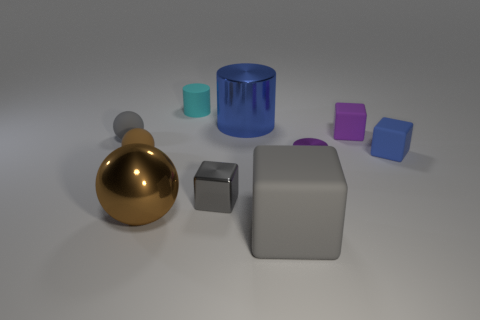Subtract all tiny purple blocks. How many blocks are left? 3 Subtract all gray cubes. How many cubes are left? 2 Subtract all blue balls. How many gray cubes are left? 2 Subtract 4 cubes. How many cubes are left? 0 Add 5 big rubber objects. How many big rubber objects are left? 6 Add 8 big gray cubes. How many big gray cubes exist? 9 Subtract 0 yellow blocks. How many objects are left? 10 Subtract all balls. How many objects are left? 7 Subtract all blue spheres. Subtract all gray cubes. How many spheres are left? 3 Subtract all purple rubber blocks. Subtract all brown metallic balls. How many objects are left? 8 